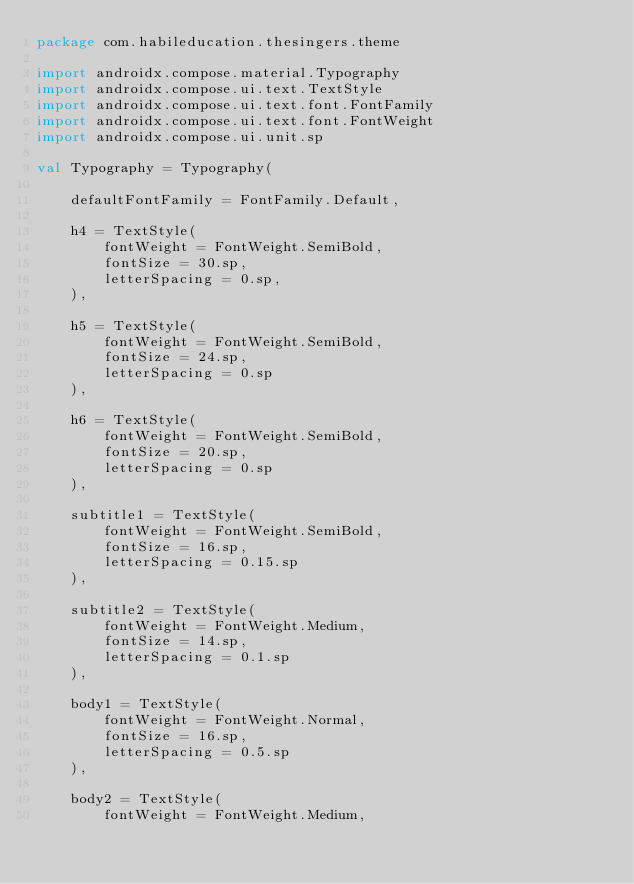<code> <loc_0><loc_0><loc_500><loc_500><_Kotlin_>package com.habileducation.thesingers.theme

import androidx.compose.material.Typography
import androidx.compose.ui.text.TextStyle
import androidx.compose.ui.text.font.FontFamily
import androidx.compose.ui.text.font.FontWeight
import androidx.compose.ui.unit.sp

val Typography = Typography(

    defaultFontFamily = FontFamily.Default,

    h4 = TextStyle(
        fontWeight = FontWeight.SemiBold,
        fontSize = 30.sp,
        letterSpacing = 0.sp,
    ),

    h5 = TextStyle(
        fontWeight = FontWeight.SemiBold,
        fontSize = 24.sp,
        letterSpacing = 0.sp
    ),

    h6 = TextStyle(
        fontWeight = FontWeight.SemiBold,
        fontSize = 20.sp,
        letterSpacing = 0.sp
    ),

    subtitle1 = TextStyle(
        fontWeight = FontWeight.SemiBold,
        fontSize = 16.sp,
        letterSpacing = 0.15.sp
    ),

    subtitle2 = TextStyle(
        fontWeight = FontWeight.Medium,
        fontSize = 14.sp,
        letterSpacing = 0.1.sp
    ),

    body1 = TextStyle(
        fontWeight = FontWeight.Normal,
        fontSize = 16.sp,
        letterSpacing = 0.5.sp
    ),

    body2 = TextStyle(
        fontWeight = FontWeight.Medium,</code> 